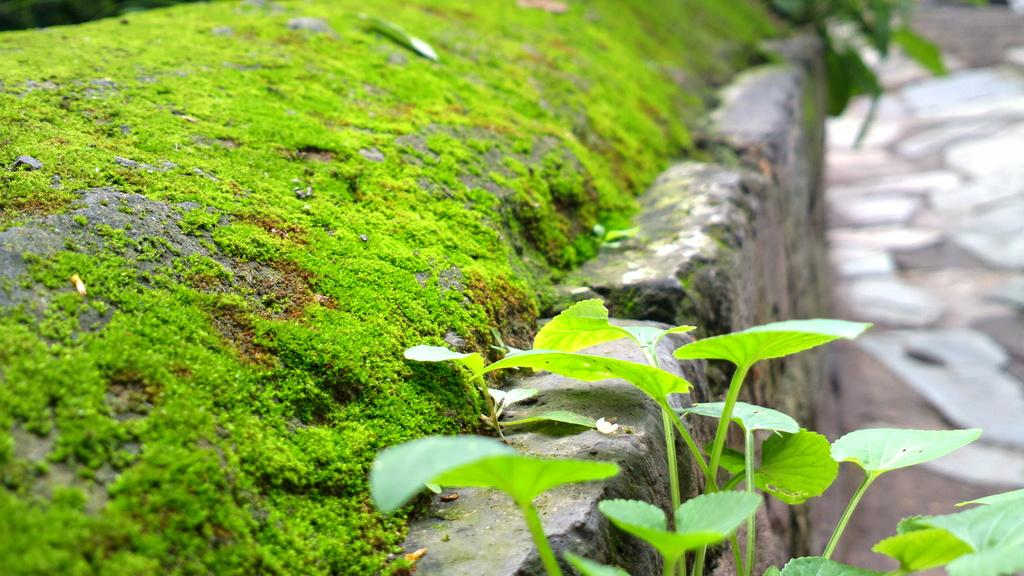What can be seen in the foreground of the picture? In the foreground of the picture, there are plants, a wall, grass, and soil. What type of vegetation is present in the foreground? The vegetation in the foreground consists of plants. What is the texture of the ground in the foreground? The ground in the foreground is covered with soil. How is the background of the image depicted? The background of the image is blurred. What type of sponge is being used to clean the shirt in the image? There is no sponge or shirt present in the image. How many bikes are visible in the image? There are no bikes visible in the image. 